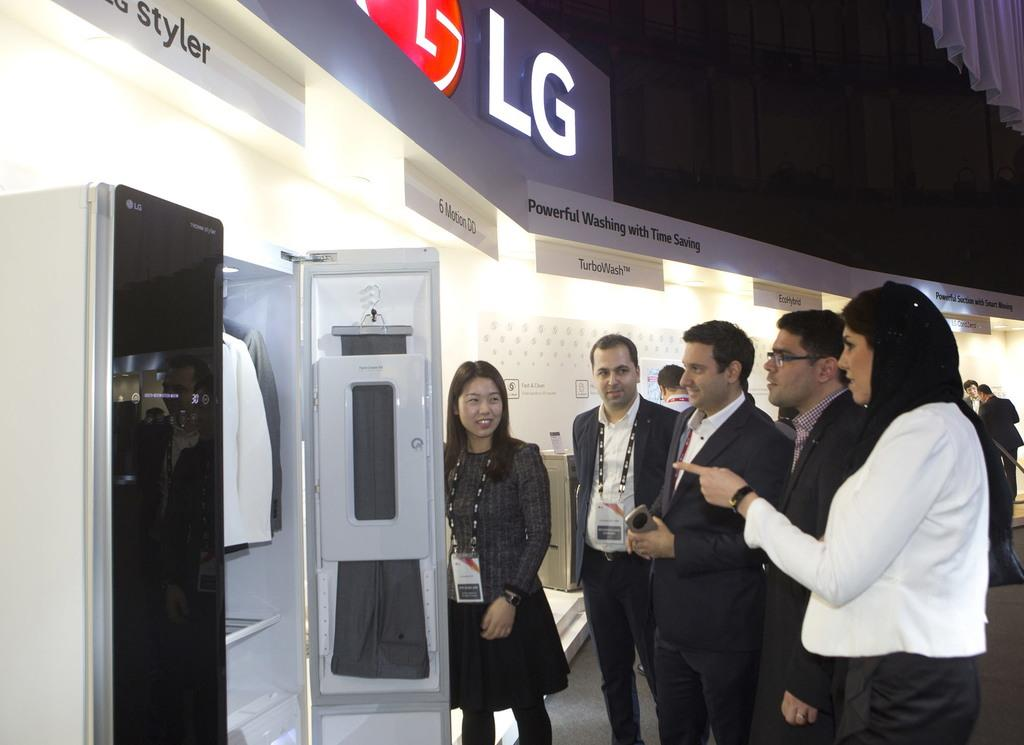<image>
Present a compact description of the photo's key features. lg booth with several overhead signs such as styler, 6 motion 00, turbowash 